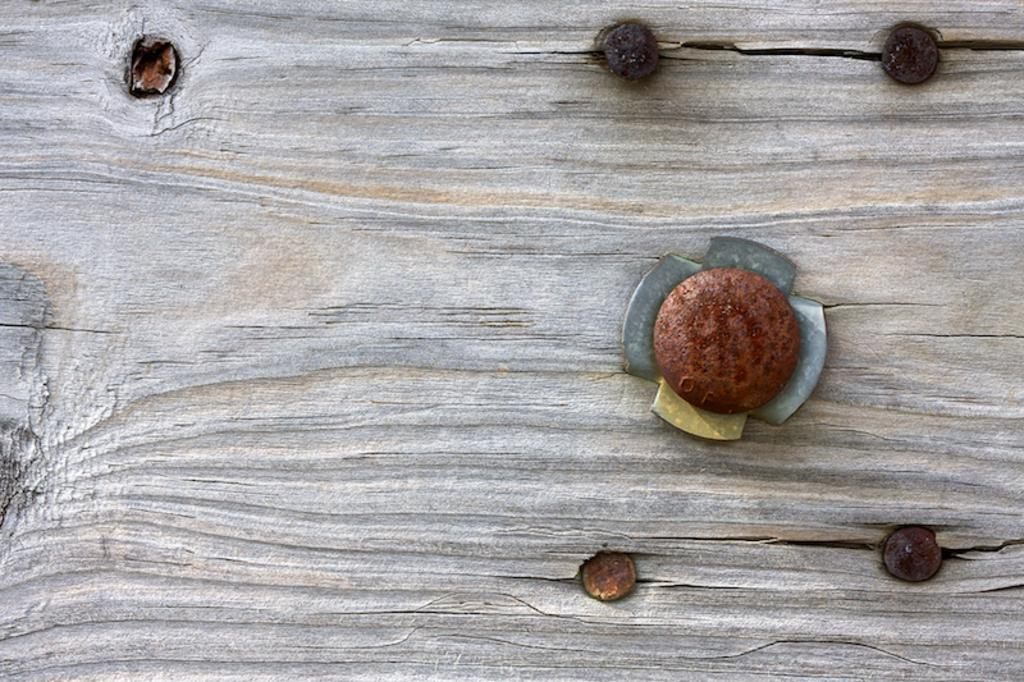What type of surface is visible in the image? There is a wooden surface in the image. What can be found on the wooden surface? There are nails on the wooden surface. What type of pencil is being used to copy the glass in the image? There is no pencil, copying, or glass present in the image. 